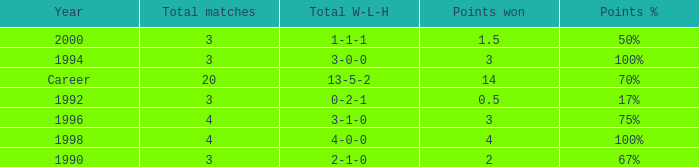Can you tell me the lowest Points won that has the Total matches of 4, and the Total W-L-H of 4-0-0? 4.0. 